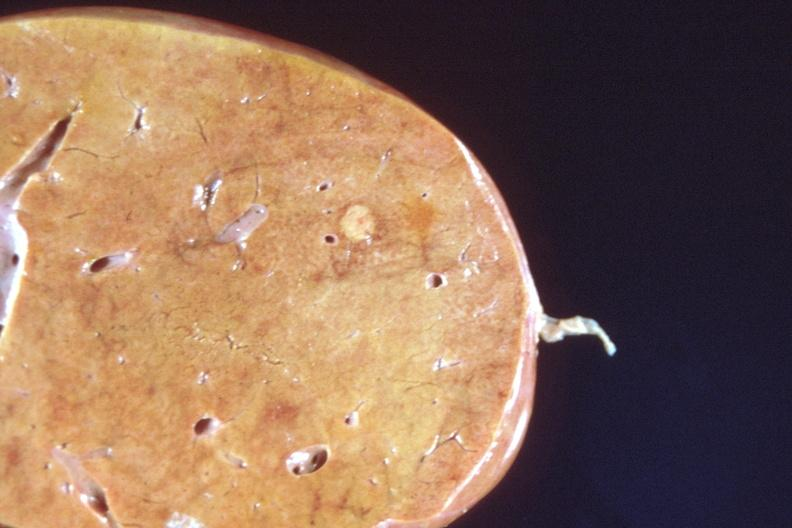what is present?
Answer the question using a single word or phrase. Hepatobiliary 